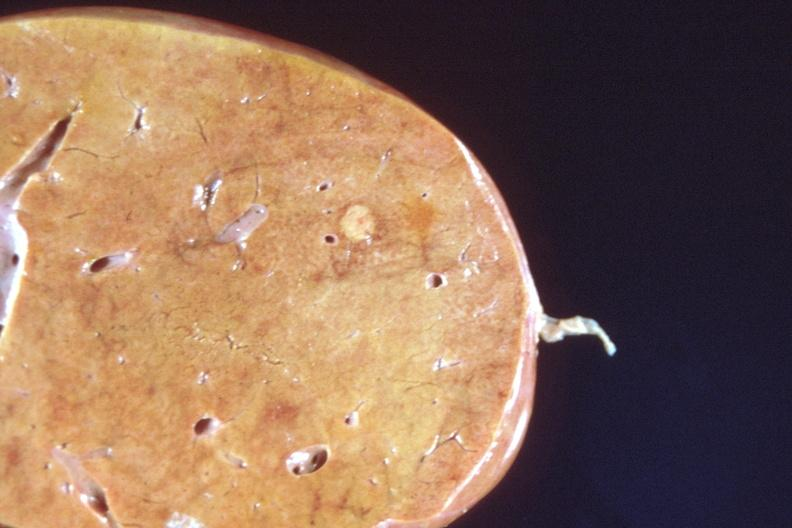what is present?
Answer the question using a single word or phrase. Hepatobiliary 